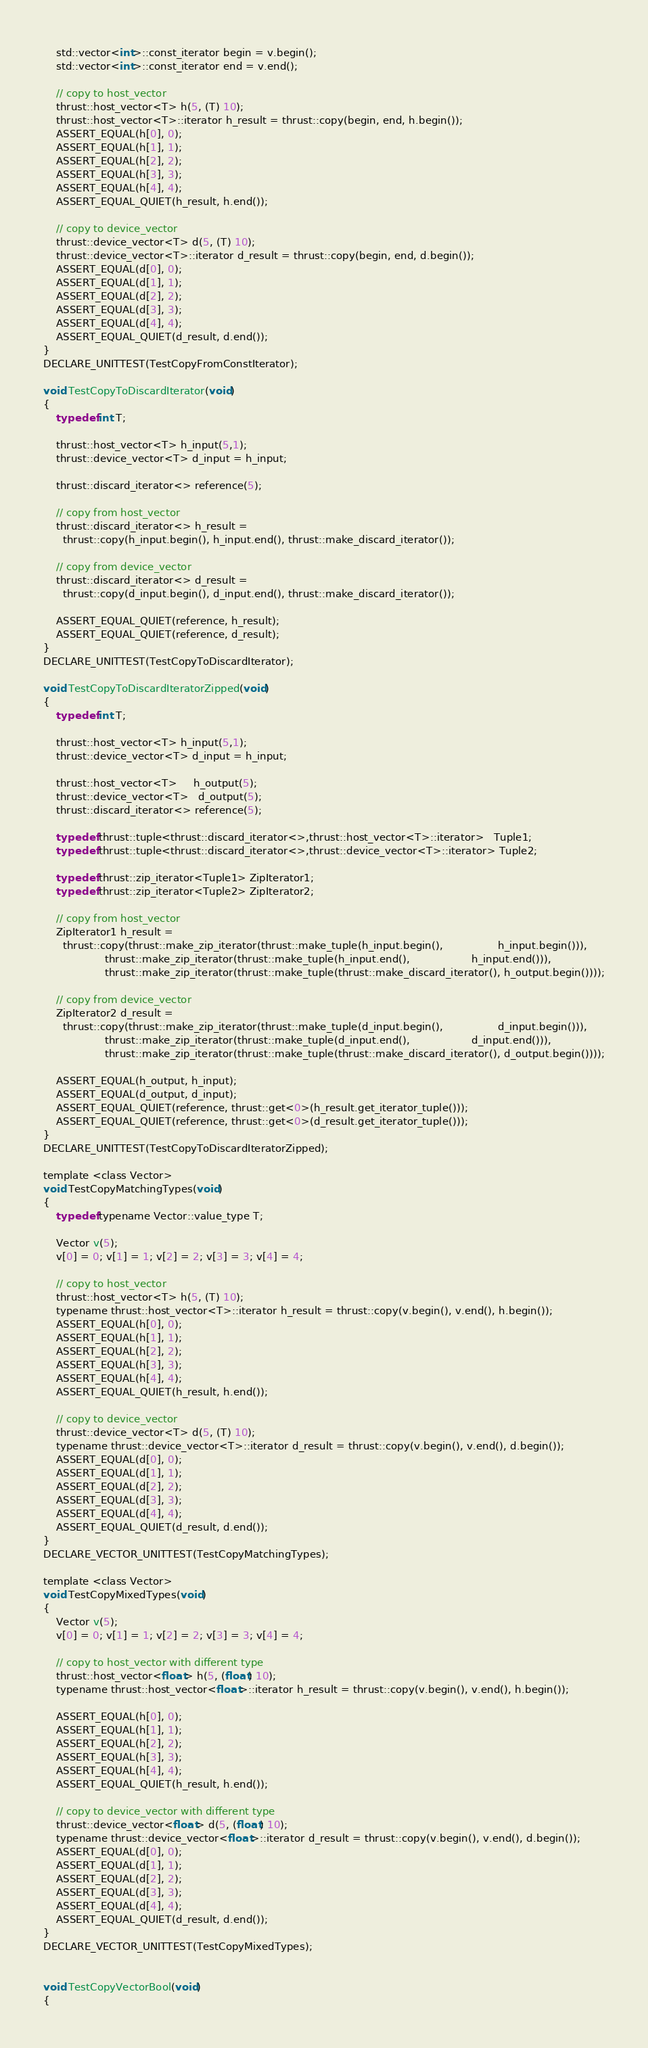Convert code to text. <code><loc_0><loc_0><loc_500><loc_500><_Cuda_>    std::vector<int>::const_iterator begin = v.begin();
    std::vector<int>::const_iterator end = v.end();

    // copy to host_vector
    thrust::host_vector<T> h(5, (T) 10);
    thrust::host_vector<T>::iterator h_result = thrust::copy(begin, end, h.begin());
    ASSERT_EQUAL(h[0], 0);
    ASSERT_EQUAL(h[1], 1);
    ASSERT_EQUAL(h[2], 2);
    ASSERT_EQUAL(h[3], 3);
    ASSERT_EQUAL(h[4], 4);
    ASSERT_EQUAL_QUIET(h_result, h.end());

    // copy to device_vector
    thrust::device_vector<T> d(5, (T) 10);
    thrust::device_vector<T>::iterator d_result = thrust::copy(begin, end, d.begin());
    ASSERT_EQUAL(d[0], 0);
    ASSERT_EQUAL(d[1], 1);
    ASSERT_EQUAL(d[2], 2);
    ASSERT_EQUAL(d[3], 3);
    ASSERT_EQUAL(d[4], 4);
    ASSERT_EQUAL_QUIET(d_result, d.end());
}
DECLARE_UNITTEST(TestCopyFromConstIterator);

void TestCopyToDiscardIterator(void)
{
    typedef int T;

    thrust::host_vector<T> h_input(5,1);
    thrust::device_vector<T> d_input = h_input;

    thrust::discard_iterator<> reference(5);

    // copy from host_vector
    thrust::discard_iterator<> h_result =
      thrust::copy(h_input.begin(), h_input.end(), thrust::make_discard_iterator());

    // copy from device_vector
    thrust::discard_iterator<> d_result =
      thrust::copy(d_input.begin(), d_input.end(), thrust::make_discard_iterator());

    ASSERT_EQUAL_QUIET(reference, h_result);
    ASSERT_EQUAL_QUIET(reference, d_result);
}
DECLARE_UNITTEST(TestCopyToDiscardIterator);

void TestCopyToDiscardIteratorZipped(void)
{
    typedef int T;

    thrust::host_vector<T> h_input(5,1);
    thrust::device_vector<T> d_input = h_input;

    thrust::host_vector<T>     h_output(5);
    thrust::device_vector<T>   d_output(5);
    thrust::discard_iterator<> reference(5);

    typedef thrust::tuple<thrust::discard_iterator<>,thrust::host_vector<T>::iterator>   Tuple1;
    typedef thrust::tuple<thrust::discard_iterator<>,thrust::device_vector<T>::iterator> Tuple2;

    typedef thrust::zip_iterator<Tuple1> ZipIterator1;
    typedef thrust::zip_iterator<Tuple2> ZipIterator2;

    // copy from host_vector
    ZipIterator1 h_result =
      thrust::copy(thrust::make_zip_iterator(thrust::make_tuple(h_input.begin(),                 h_input.begin())),
                   thrust::make_zip_iterator(thrust::make_tuple(h_input.end(),                   h_input.end())),
                   thrust::make_zip_iterator(thrust::make_tuple(thrust::make_discard_iterator(), h_output.begin())));

    // copy from device_vector
    ZipIterator2 d_result =
      thrust::copy(thrust::make_zip_iterator(thrust::make_tuple(d_input.begin(),                 d_input.begin())),
                   thrust::make_zip_iterator(thrust::make_tuple(d_input.end(),                   d_input.end())),
                   thrust::make_zip_iterator(thrust::make_tuple(thrust::make_discard_iterator(), d_output.begin())));

    ASSERT_EQUAL(h_output, h_input);
    ASSERT_EQUAL(d_output, d_input);
    ASSERT_EQUAL_QUIET(reference, thrust::get<0>(h_result.get_iterator_tuple()));
    ASSERT_EQUAL_QUIET(reference, thrust::get<0>(d_result.get_iterator_tuple()));
}
DECLARE_UNITTEST(TestCopyToDiscardIteratorZipped);

template <class Vector>
void TestCopyMatchingTypes(void)
{
    typedef typename Vector::value_type T;

    Vector v(5);
    v[0] = 0; v[1] = 1; v[2] = 2; v[3] = 3; v[4] = 4;

    // copy to host_vector
    thrust::host_vector<T> h(5, (T) 10);
    typename thrust::host_vector<T>::iterator h_result = thrust::copy(v.begin(), v.end(), h.begin());
    ASSERT_EQUAL(h[0], 0);
    ASSERT_EQUAL(h[1], 1);
    ASSERT_EQUAL(h[2], 2);
    ASSERT_EQUAL(h[3], 3);
    ASSERT_EQUAL(h[4], 4);
    ASSERT_EQUAL_QUIET(h_result, h.end());

    // copy to device_vector
    thrust::device_vector<T> d(5, (T) 10);
    typename thrust::device_vector<T>::iterator d_result = thrust::copy(v.begin(), v.end(), d.begin());
    ASSERT_EQUAL(d[0], 0);
    ASSERT_EQUAL(d[1], 1);
    ASSERT_EQUAL(d[2], 2);
    ASSERT_EQUAL(d[3], 3);
    ASSERT_EQUAL(d[4], 4);
    ASSERT_EQUAL_QUIET(d_result, d.end());
}
DECLARE_VECTOR_UNITTEST(TestCopyMatchingTypes);

template <class Vector>
void TestCopyMixedTypes(void)
{
    Vector v(5);
    v[0] = 0; v[1] = 1; v[2] = 2; v[3] = 3; v[4] = 4;

    // copy to host_vector with different type
    thrust::host_vector<float> h(5, (float) 10);
    typename thrust::host_vector<float>::iterator h_result = thrust::copy(v.begin(), v.end(), h.begin());

    ASSERT_EQUAL(h[0], 0);
    ASSERT_EQUAL(h[1], 1);
    ASSERT_EQUAL(h[2], 2);
    ASSERT_EQUAL(h[3], 3);
    ASSERT_EQUAL(h[4], 4);
    ASSERT_EQUAL_QUIET(h_result, h.end());

    // copy to device_vector with different type
    thrust::device_vector<float> d(5, (float) 10);
    typename thrust::device_vector<float>::iterator d_result = thrust::copy(v.begin(), v.end(), d.begin());
    ASSERT_EQUAL(d[0], 0);
    ASSERT_EQUAL(d[1], 1);
    ASSERT_EQUAL(d[2], 2);
    ASSERT_EQUAL(d[3], 3);
    ASSERT_EQUAL(d[4], 4);
    ASSERT_EQUAL_QUIET(d_result, d.end());
}
DECLARE_VECTOR_UNITTEST(TestCopyMixedTypes);


void TestCopyVectorBool(void)
{</code> 